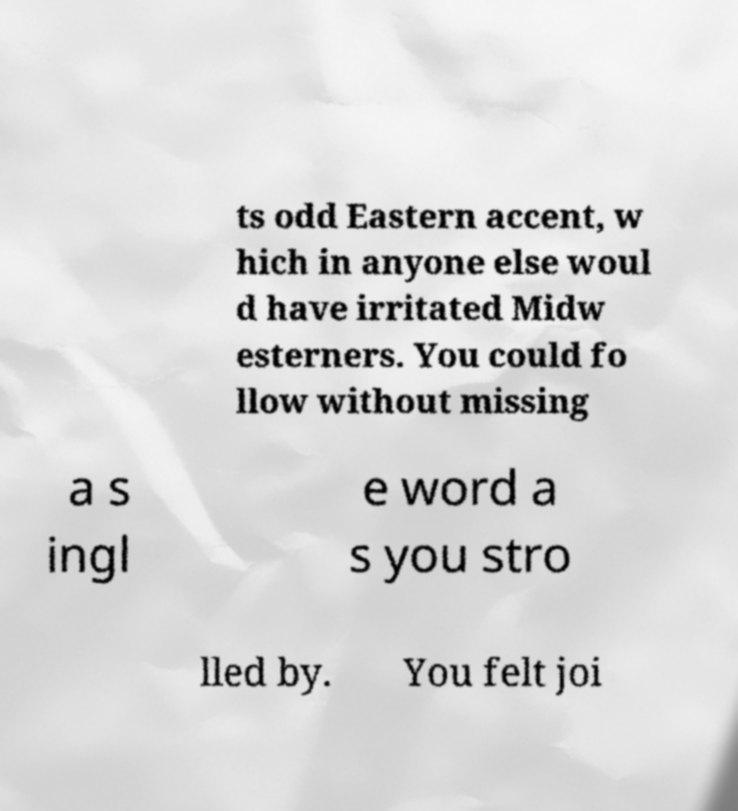Can you read and provide the text displayed in the image?This photo seems to have some interesting text. Can you extract and type it out for me? ts odd Eastern accent, w hich in anyone else woul d have irritated Midw esterners. You could fo llow without missing a s ingl e word a s you stro lled by. You felt joi 